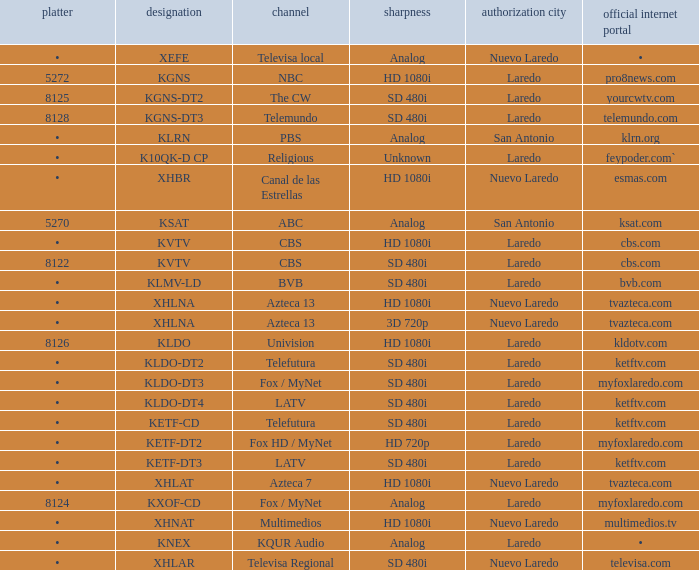Name the official website which has dish of • and callsign of kvtv Cbs.com. 